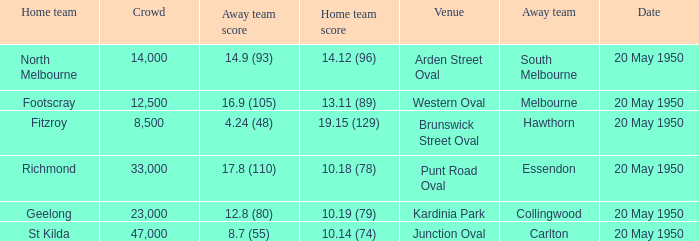What was the score for the away team that played against Richmond and has a crowd over 12,500? 17.8 (110). 